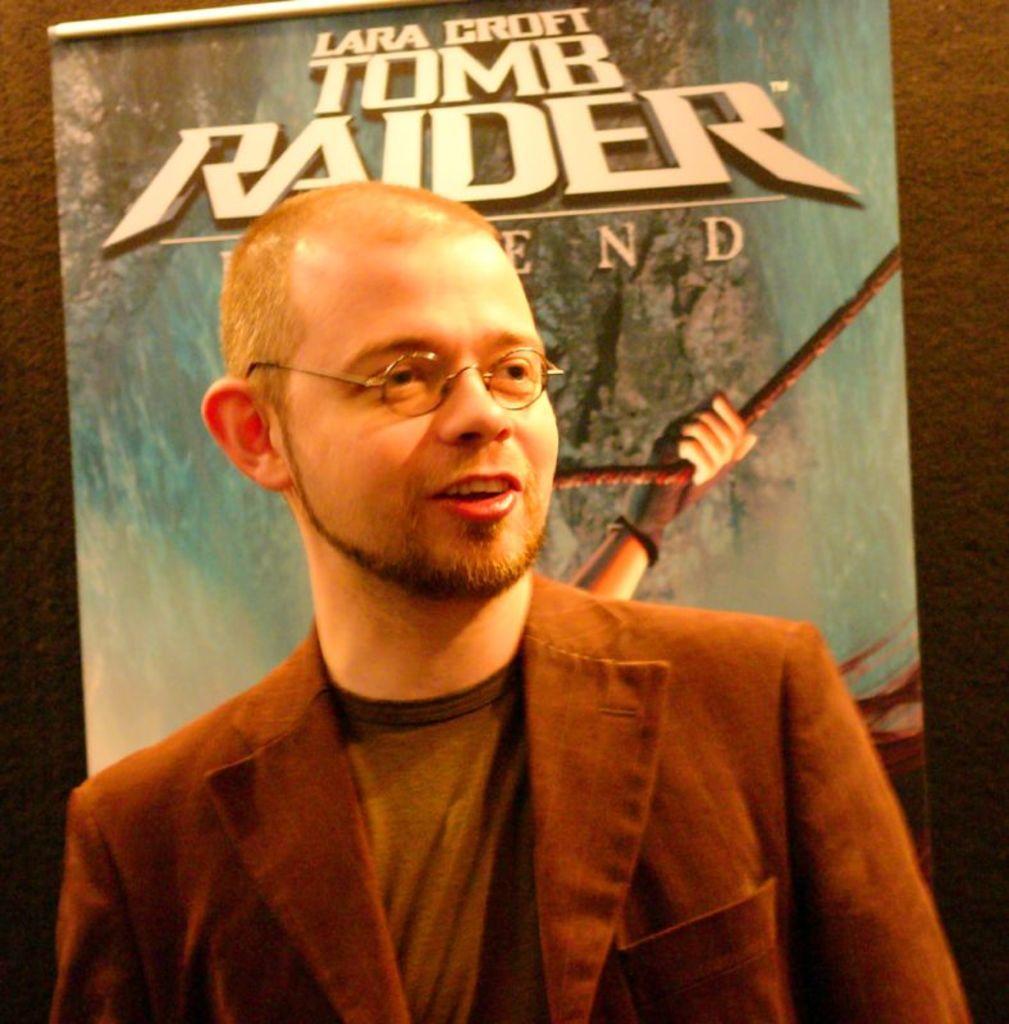Can you describe this image briefly? There is a man standing and wore spectacle. In the background we can see banner on a wall. 